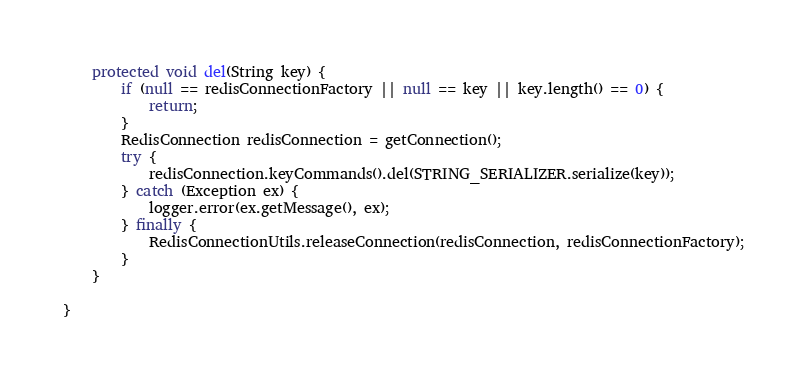<code> <loc_0><loc_0><loc_500><loc_500><_Java_>    protected void del(String key) {
        if (null == redisConnectionFactory || null == key || key.length() == 0) {
            return;
        }
        RedisConnection redisConnection = getConnection();
        try {
            redisConnection.keyCommands().del(STRING_SERIALIZER.serialize(key));
        } catch (Exception ex) {
            logger.error(ex.getMessage(), ex);
        } finally {
            RedisConnectionUtils.releaseConnection(redisConnection, redisConnectionFactory);
        }
    }

}
</code> 